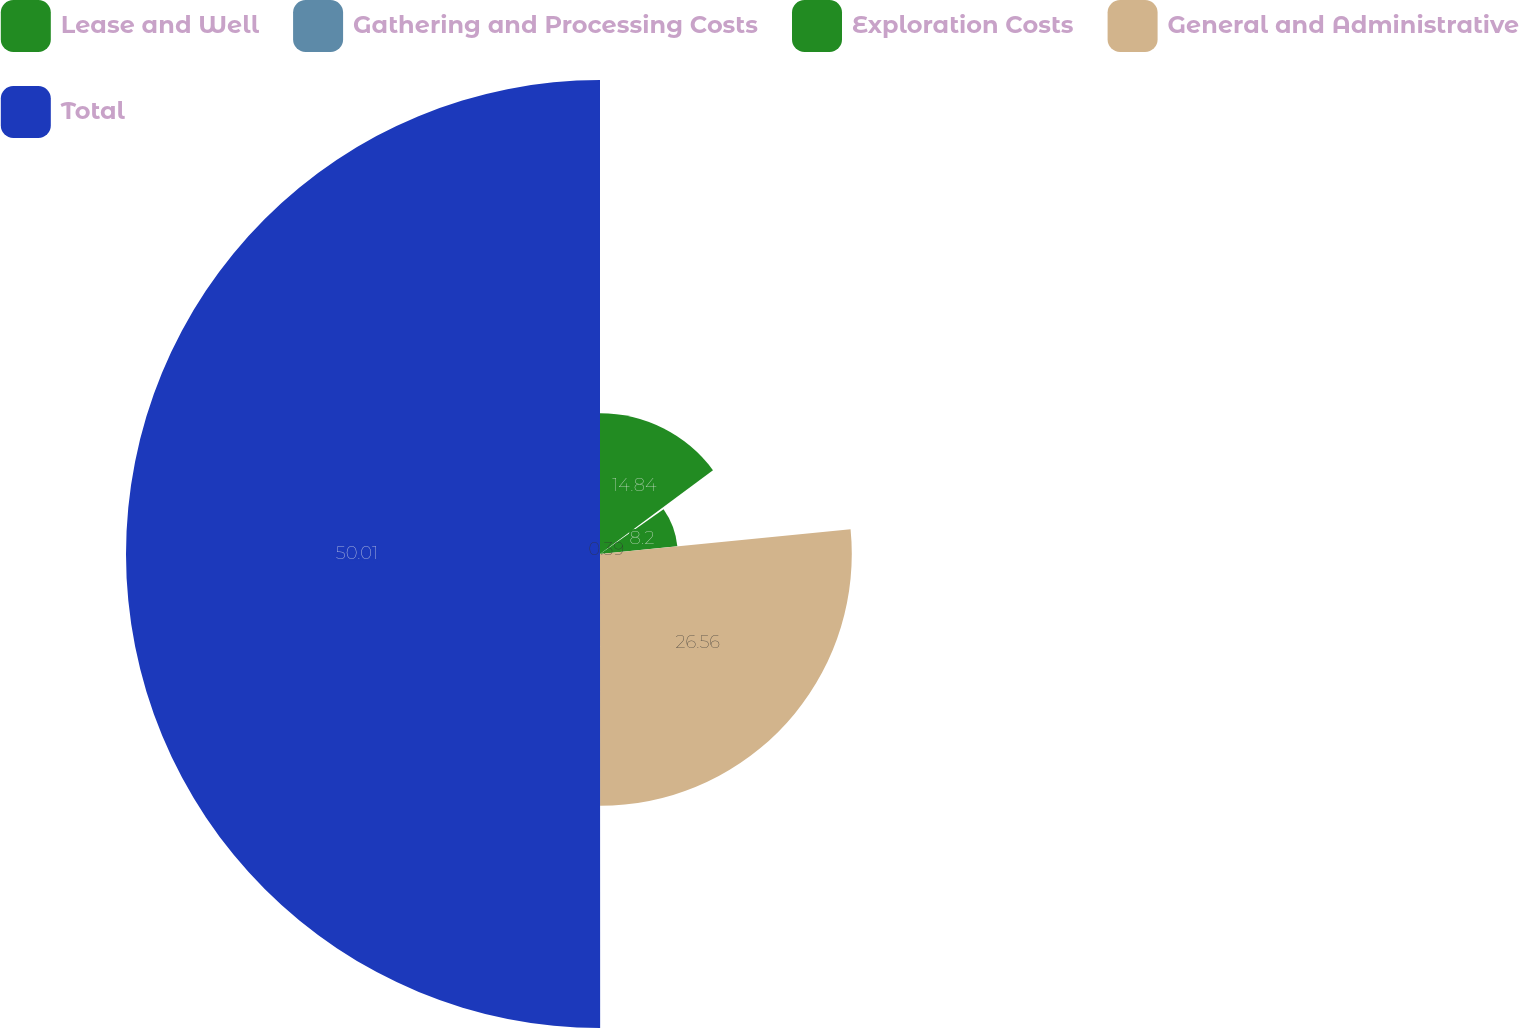<chart> <loc_0><loc_0><loc_500><loc_500><pie_chart><fcel>Lease and Well<fcel>Gathering and Processing Costs<fcel>Exploration Costs<fcel>General and Administrative<fcel>Total<nl><fcel>14.84%<fcel>0.39%<fcel>8.2%<fcel>26.56%<fcel>50.0%<nl></chart> 